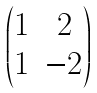<formula> <loc_0><loc_0><loc_500><loc_500>\begin{pmatrix} 1 & 2 \\ 1 & - 2 \end{pmatrix}</formula> 